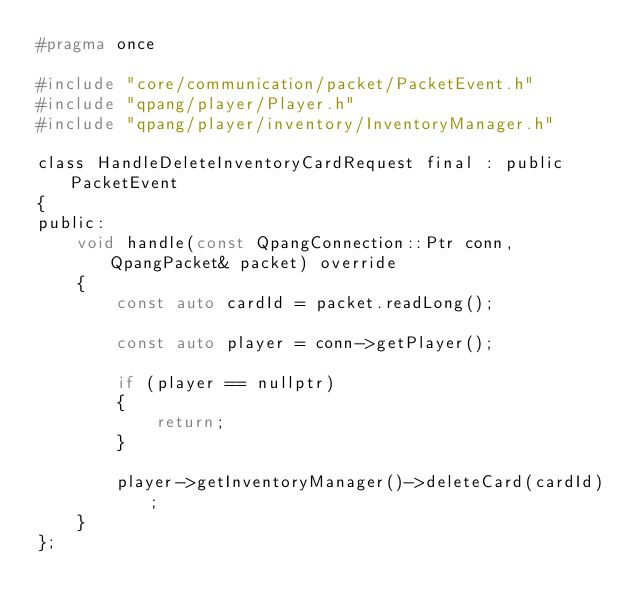Convert code to text. <code><loc_0><loc_0><loc_500><loc_500><_C_>#pragma once

#include "core/communication/packet/PacketEvent.h"
#include "qpang/player/Player.h"
#include "qpang/player/inventory/InventoryManager.h"

class HandleDeleteInventoryCardRequest final : public PacketEvent
{
public:
	void handle(const QpangConnection::Ptr conn, QpangPacket& packet) override
	{
		const auto cardId = packet.readLong();

		const auto player = conn->getPlayer();

		if (player == nullptr)
		{
			return;
		}

		player->getInventoryManager()->deleteCard(cardId);
	}
};
</code> 